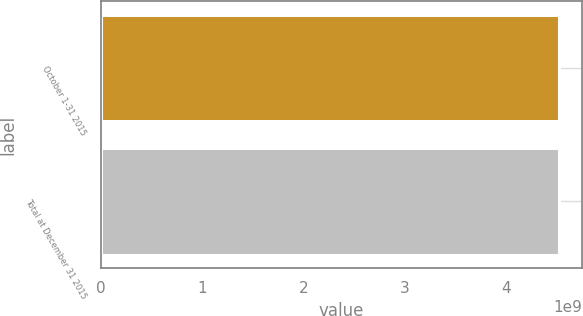<chart> <loc_0><loc_0><loc_500><loc_500><bar_chart><fcel>October 1-31 2015<fcel>Total at December 31 2015<nl><fcel>4.52153e+09<fcel>4.52153e+09<nl></chart> 